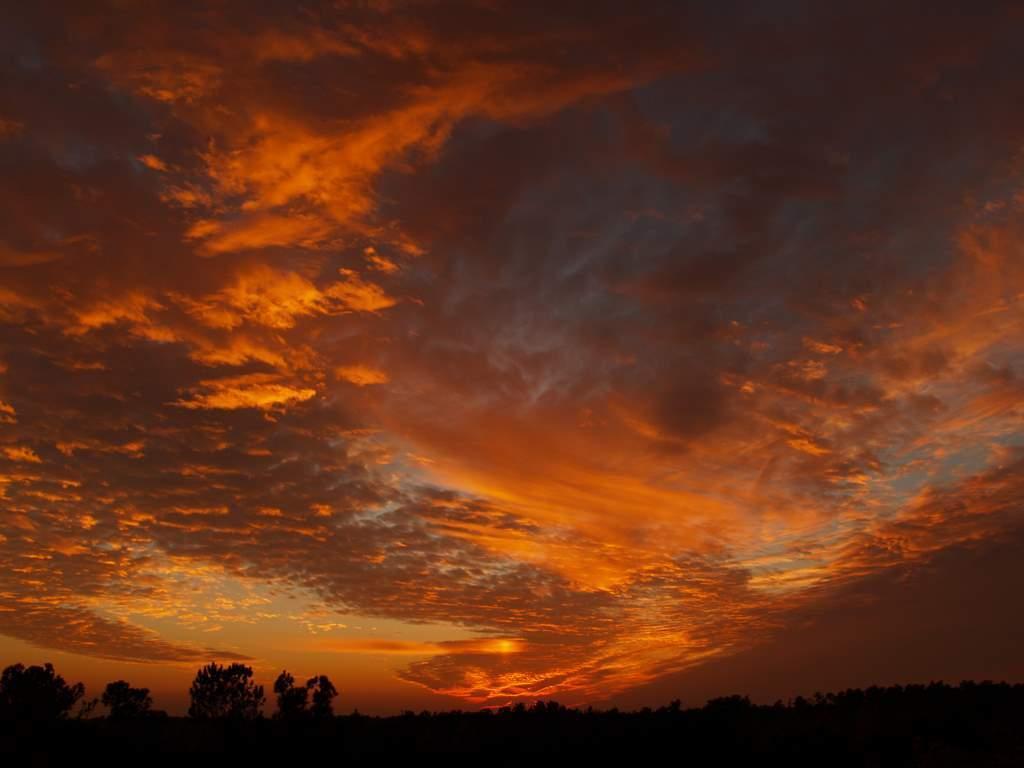Describe this image in one or two sentences. In this image, we can see a cloudy sky. At the bottom of the image, we can see so many trees. 